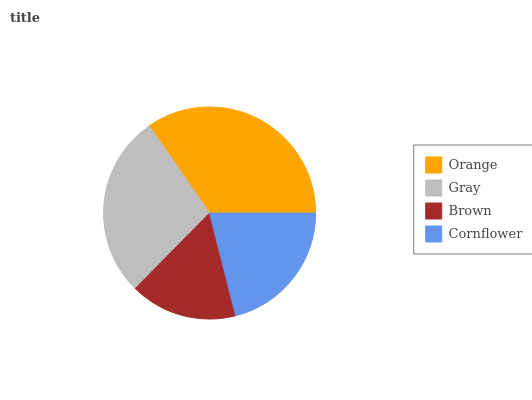Is Brown the minimum?
Answer yes or no. Yes. Is Orange the maximum?
Answer yes or no. Yes. Is Gray the minimum?
Answer yes or no. No. Is Gray the maximum?
Answer yes or no. No. Is Orange greater than Gray?
Answer yes or no. Yes. Is Gray less than Orange?
Answer yes or no. Yes. Is Gray greater than Orange?
Answer yes or no. No. Is Orange less than Gray?
Answer yes or no. No. Is Gray the high median?
Answer yes or no. Yes. Is Cornflower the low median?
Answer yes or no. Yes. Is Cornflower the high median?
Answer yes or no. No. Is Orange the low median?
Answer yes or no. No. 